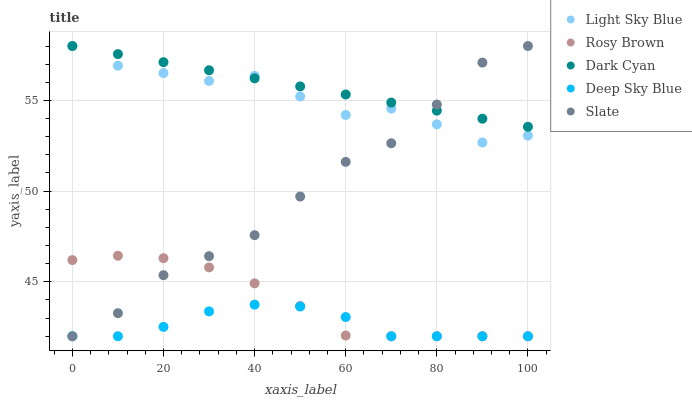Does Deep Sky Blue have the minimum area under the curve?
Answer yes or no. Yes. Does Dark Cyan have the maximum area under the curve?
Answer yes or no. Yes. Does Rosy Brown have the minimum area under the curve?
Answer yes or no. No. Does Rosy Brown have the maximum area under the curve?
Answer yes or no. No. Is Dark Cyan the smoothest?
Answer yes or no. Yes. Is Light Sky Blue the roughest?
Answer yes or no. Yes. Is Rosy Brown the smoothest?
Answer yes or no. No. Is Rosy Brown the roughest?
Answer yes or no. No. Does Rosy Brown have the lowest value?
Answer yes or no. Yes. Does Light Sky Blue have the lowest value?
Answer yes or no. No. Does Slate have the highest value?
Answer yes or no. Yes. Does Rosy Brown have the highest value?
Answer yes or no. No. Is Rosy Brown less than Light Sky Blue?
Answer yes or no. Yes. Is Light Sky Blue greater than Rosy Brown?
Answer yes or no. Yes. Does Deep Sky Blue intersect Rosy Brown?
Answer yes or no. Yes. Is Deep Sky Blue less than Rosy Brown?
Answer yes or no. No. Is Deep Sky Blue greater than Rosy Brown?
Answer yes or no. No. Does Rosy Brown intersect Light Sky Blue?
Answer yes or no. No. 